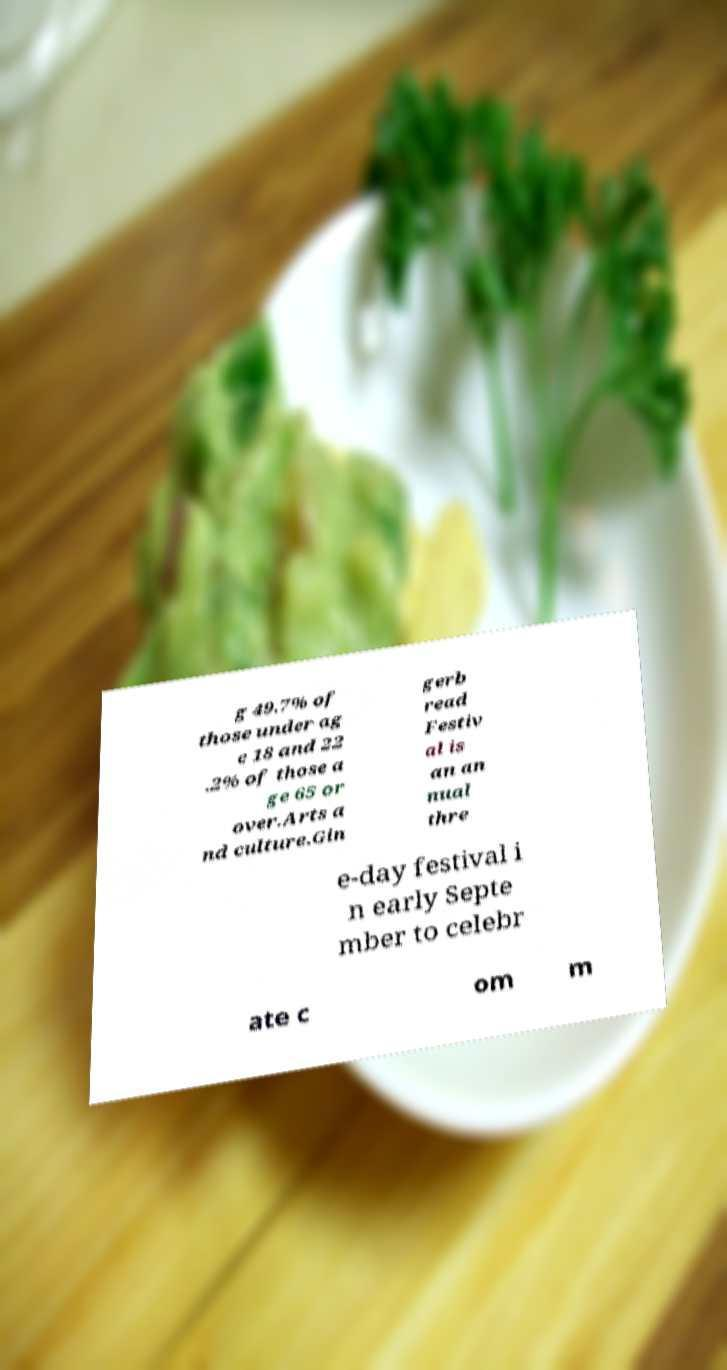Could you assist in decoding the text presented in this image and type it out clearly? g 49.7% of those under ag e 18 and 22 .2% of those a ge 65 or over.Arts a nd culture.Gin gerb read Festiv al is an an nual thre e-day festival i n early Septe mber to celebr ate c om m 